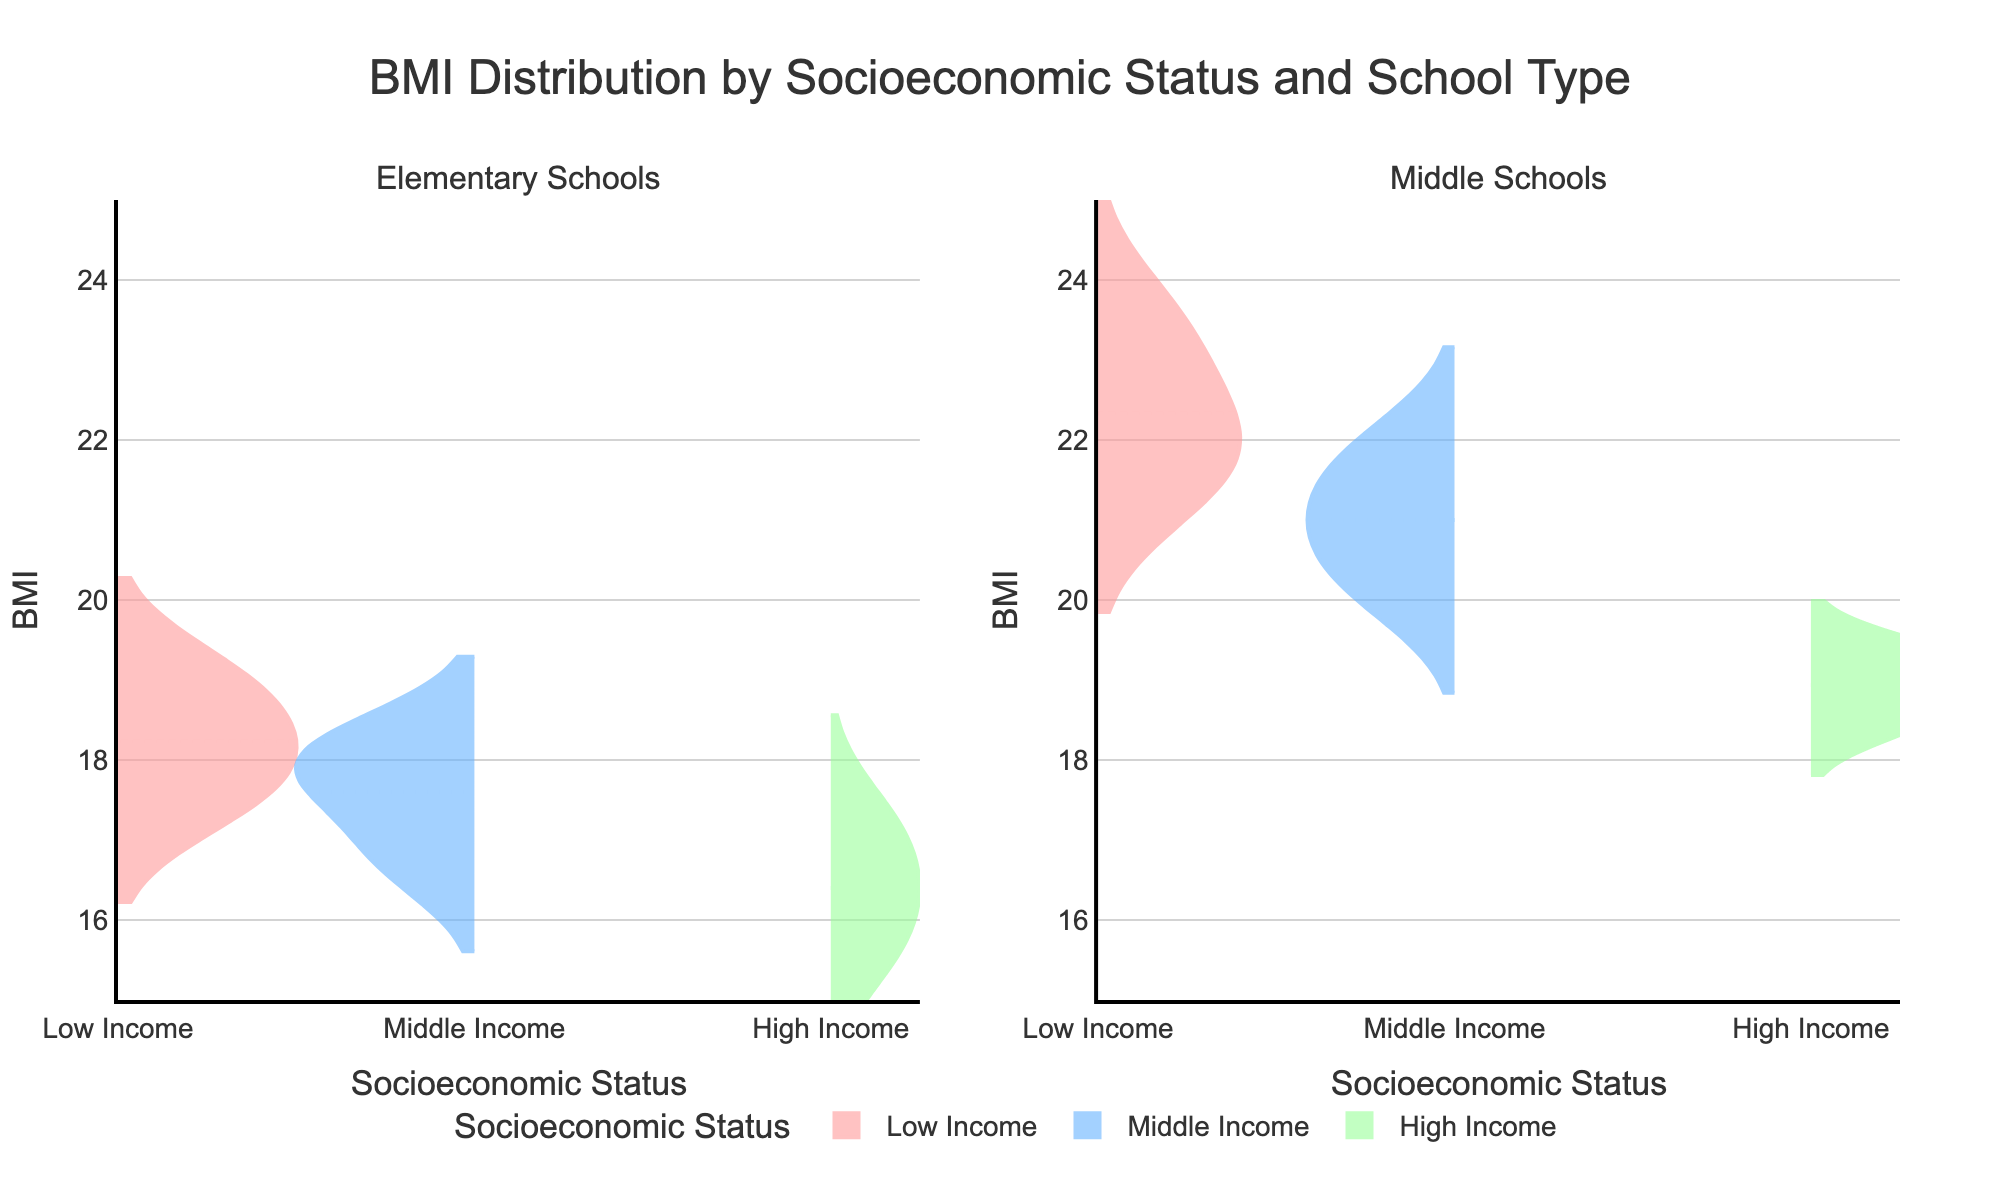How many socioeconomic statuses are depicted in the figure? The title of the figure mentions "Socioeconomic Status" and the legend displays different categories. By counting the distinct categories in the legend, we can identify three: Low Income, Middle Income, and High Income
Answer: Three What does the y-axis represent in the figure? By referring to the y-axis label, it clearly indicates that the y-axis represents BMI
Answer: BMI Between Low Income and Middle Income students in Middle Schools, which group shows a higher average BMI? By examining the mean lines within the violins for both groups in the Middle Schools subplot, it appears that the Low Income group has a higher average BMI compared to the Middle Income group
Answer: Low Income Which type of school shows the widest distribution of BMIs among High Income students? By comparing the width of the violins for High Income students in both Elementary and Middle Schools, the violin for Elementary Schools is wider, indicating a broader distribution
Answer: Elementary Schools Do Low Income students in Elementary Schools generally have higher BMIs than High Income students in Middle Schools? By comparing the mean lines for Low Income students in Elementary Schools and High Income students in Middle Schools, the mean BMI for the Low Income group in Elementary Schools appears to be higher
Answer: Yes What color represents Middle Income students in the figure? By referring to the color legend in the figure, Middle Income students are represented by the color blue
Answer: Blue Between Elementary Schools and Middle Schools, where is the difference in average BMI among socioeconomic statuses more pronounced? By comparing the spread and separation of the mean lines across different SES categories in both subplots, the difference among the categories appears more pronounced in the Middle Schools subplot
Answer: Middle Schools Which socioeconomic status group shows the smallest spread of BMI in Middle Schools? By observing the narrowest width of the violin in the Middle Schools subplot, the High Income group shows the smallest spread of BMI
Answer: High Income Are there any significant differences in BMI distributions between genders within the socioeconomic status groups? Since the plot does not differentiate between genders within the socioeconomic status groups, we cannot determine this information from the figure
Answer: Not enough data Is the overall trend in BMI higher or lower for Middle Income students compared to Low Income students? By comparing the mean lines of Middle Income and Low Income groups across both Elementary and Middle Schools, the overall trend shows that Middle Income students tend to have lower BMIs compared to Low Income students
Answer: Lower 